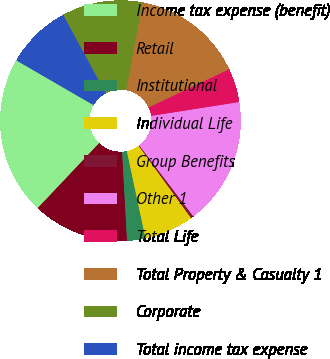Convert chart. <chart><loc_0><loc_0><loc_500><loc_500><pie_chart><fcel>Income tax expense (benefit)<fcel>Retail<fcel>Institutional<fcel>Individual Life<fcel>Group Benefits<fcel>Other 1<fcel>Total Life<fcel>Total Property & Casualty 1<fcel>Corporate<fcel>Total income tax expense<nl><fcel>21.3%<fcel>12.93%<fcel>2.47%<fcel>6.65%<fcel>0.37%<fcel>17.12%<fcel>4.56%<fcel>15.02%<fcel>10.84%<fcel>8.74%<nl></chart> 